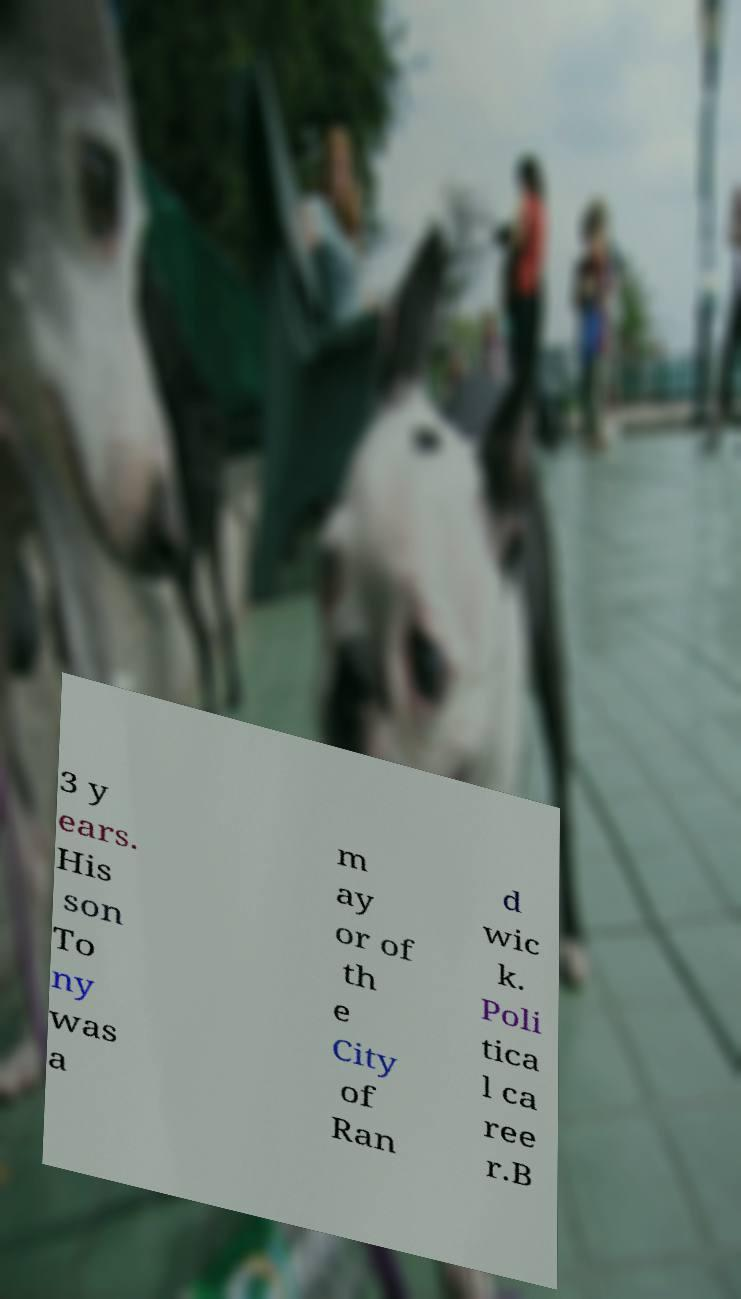Could you extract and type out the text from this image? 3 y ears. His son To ny was a m ay or of th e City of Ran d wic k. Poli tica l ca ree r.B 